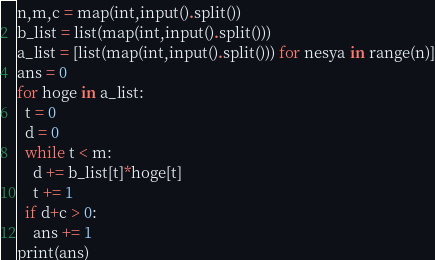<code> <loc_0><loc_0><loc_500><loc_500><_Python_>n,m,c = map(int,input().split())
b_list = list(map(int,input().split()))
a_list = [list(map(int,input().split())) for nesya in range(n)]
ans = 0
for hoge in a_list:
  t = 0
  d = 0
  while t < m:
    d += b_list[t]*hoge[t]
    t += 1
  if d+c > 0:
    ans += 1
print(ans)</code> 